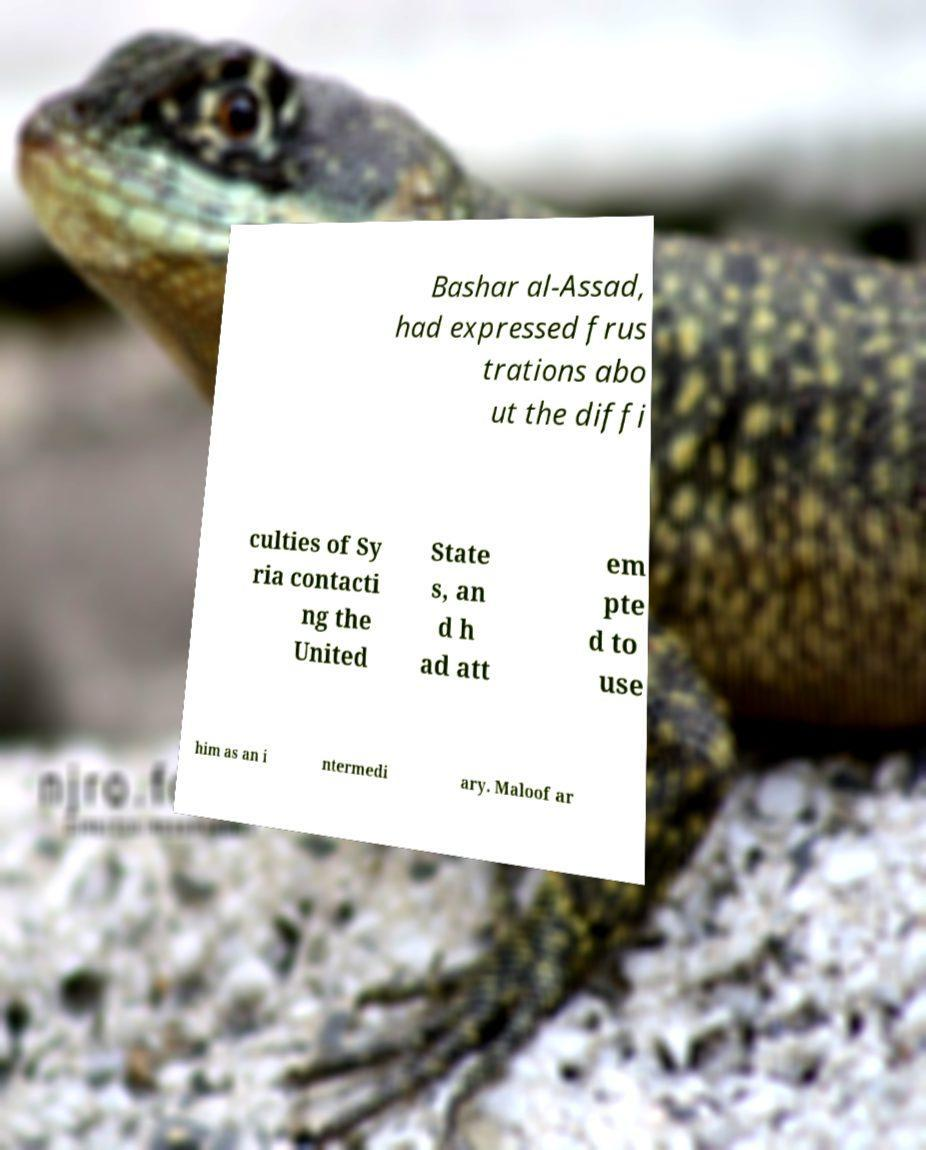Please read and relay the text visible in this image. What does it say? Bashar al-Assad, had expressed frus trations abo ut the diffi culties of Sy ria contacti ng the United State s, an d h ad att em pte d to use him as an i ntermedi ary. Maloof ar 